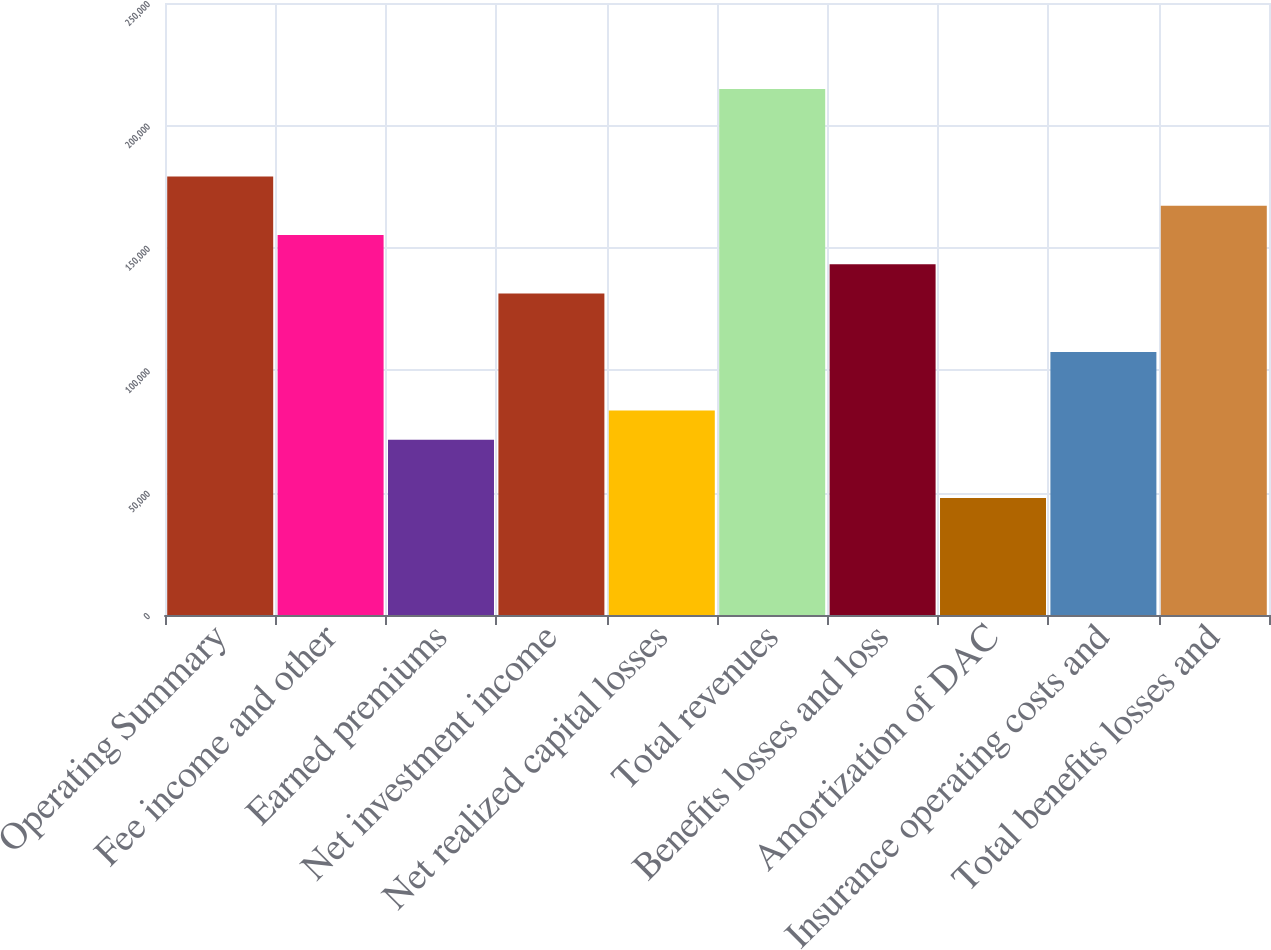Convert chart. <chart><loc_0><loc_0><loc_500><loc_500><bar_chart><fcel>Operating Summary<fcel>Fee income and other<fcel>Earned premiums<fcel>Net investment income<fcel>Net realized capital losses<fcel>Total revenues<fcel>Benefits losses and loss<fcel>Amortization of DAC<fcel>Insurance operating costs and<fcel>Total benefits losses and<nl><fcel>179076<fcel>155200<fcel>71636<fcel>131325<fcel>83573.7<fcel>214889<fcel>143263<fcel>47760.4<fcel>107449<fcel>167138<nl></chart> 